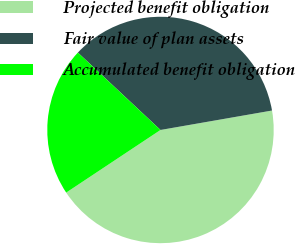Convert chart. <chart><loc_0><loc_0><loc_500><loc_500><pie_chart><fcel>Projected benefit obligation<fcel>Fair value of plan assets<fcel>Accumulated benefit obligation<nl><fcel>43.42%<fcel>35.28%<fcel>21.31%<nl></chart> 